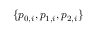<formula> <loc_0><loc_0><loc_500><loc_500>\{ p _ { 0 , i } , p _ { 1 , i } , p _ { 2 , i } \}</formula> 